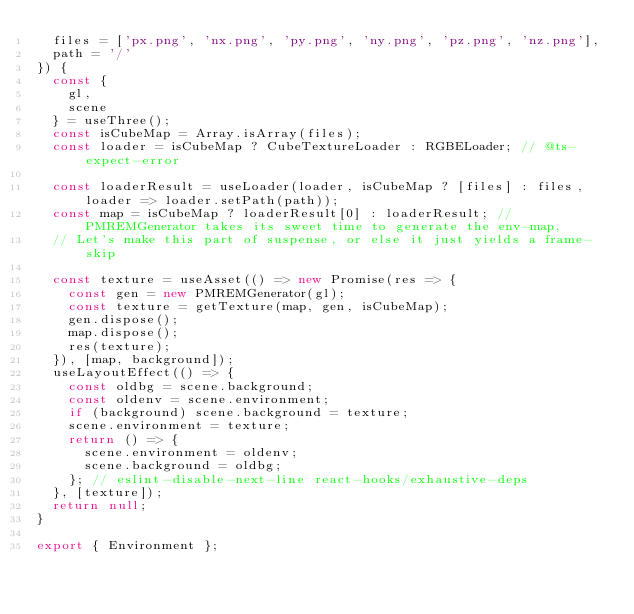<code> <loc_0><loc_0><loc_500><loc_500><_JavaScript_>  files = ['px.png', 'nx.png', 'py.png', 'ny.png', 'pz.png', 'nz.png'],
  path = '/'
}) {
  const {
    gl,
    scene
  } = useThree();
  const isCubeMap = Array.isArray(files);
  const loader = isCubeMap ? CubeTextureLoader : RGBELoader; // @ts-expect-error

  const loaderResult = useLoader(loader, isCubeMap ? [files] : files, loader => loader.setPath(path));
  const map = isCubeMap ? loaderResult[0] : loaderResult; // PMREMGenerator takes its sweet time to generate the env-map,
  // Let's make this part of suspense, or else it just yields a frame-skip

  const texture = useAsset(() => new Promise(res => {
    const gen = new PMREMGenerator(gl);
    const texture = getTexture(map, gen, isCubeMap);
    gen.dispose();
    map.dispose();
    res(texture);
  }), [map, background]);
  useLayoutEffect(() => {
    const oldbg = scene.background;
    const oldenv = scene.environment;
    if (background) scene.background = texture;
    scene.environment = texture;
    return () => {
      scene.environment = oldenv;
      scene.background = oldbg;
    }; // eslint-disable-next-line react-hooks/exhaustive-deps
  }, [texture]);
  return null;
}

export { Environment };
</code> 